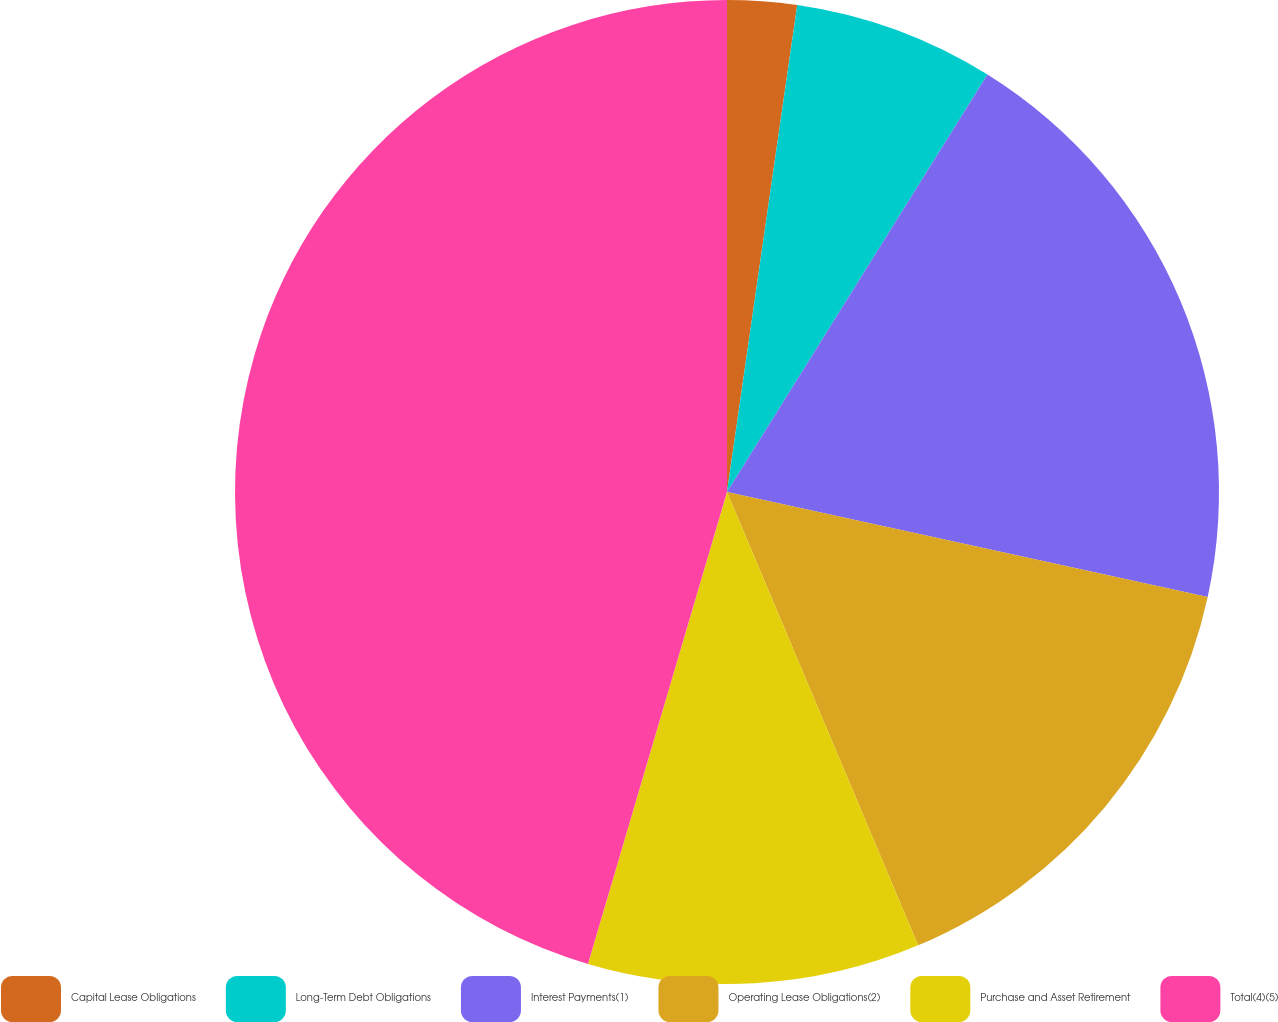<chart> <loc_0><loc_0><loc_500><loc_500><pie_chart><fcel>Capital Lease Obligations<fcel>Long-Term Debt Obligations<fcel>Interest Payments(1)<fcel>Operating Lease Obligations(2)<fcel>Purchase and Asset Retirement<fcel>Total(4)(5)<nl><fcel>2.28%<fcel>6.6%<fcel>19.54%<fcel>15.23%<fcel>10.91%<fcel>45.44%<nl></chart> 